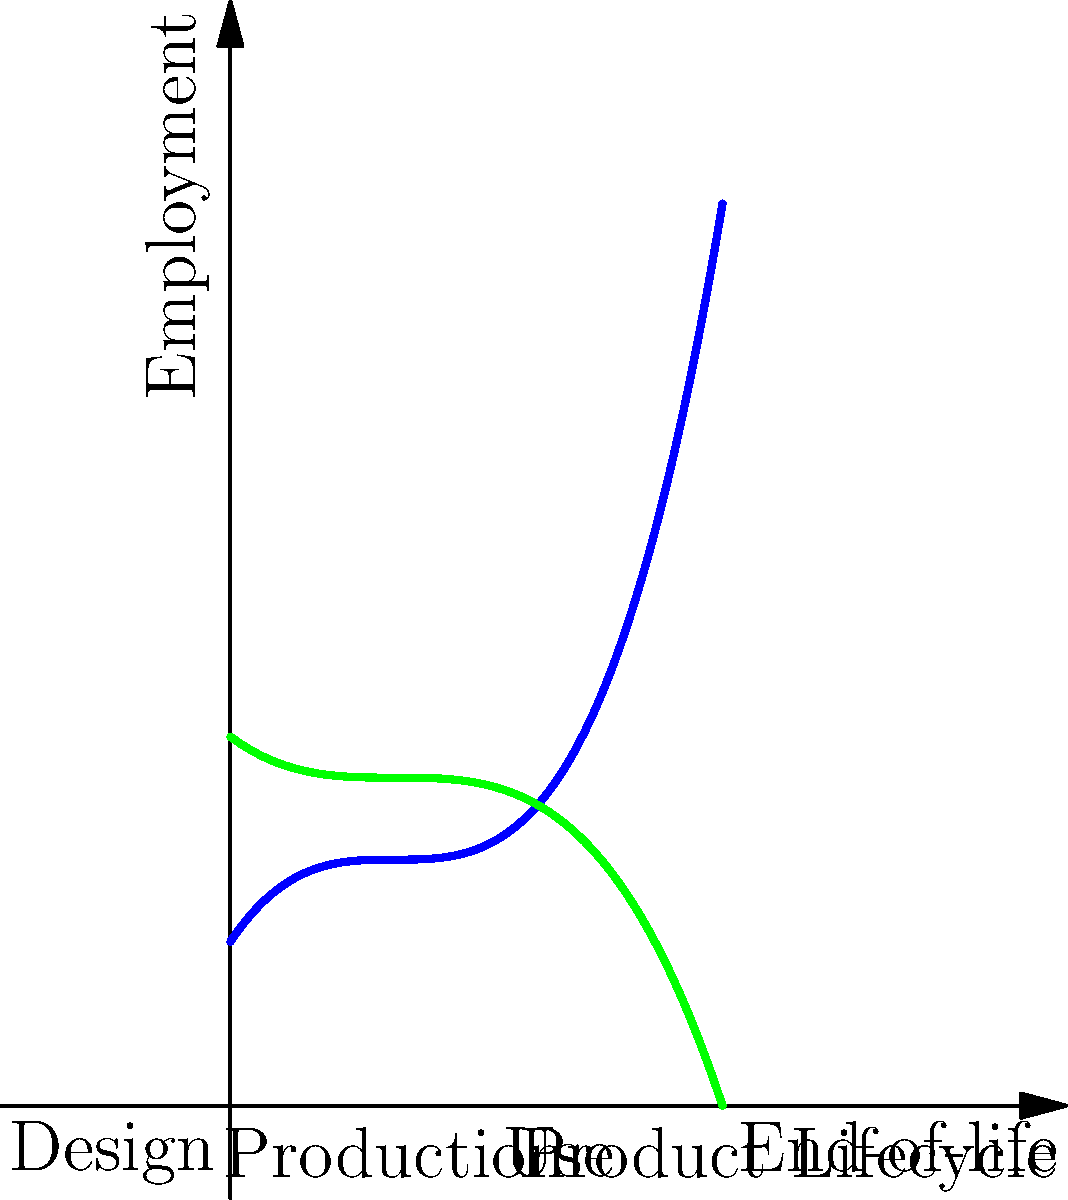In the diagram above, which model demonstrates a more stable employment trend across the product lifecycle, and how might this impact sustainable manufacturing practices? To answer this question, let's analyze the two curves representing the Linear Economy (blue) and Circular Economy (green) models:

1. Linear Economy (Blue Curve):
   - Shows high employment during the design and production phases
   - Employment declines sharply during the use phase
   - Slight increase in employment at the end-of-life phase

2. Circular Economy (Green Curve):
   - More consistent employment levels across all phases
   - Lower peak in the design and production phases compared to the linear model
   - Maintains higher employment during the use phase
   - Significant increase in employment at the end-of-life phase

3. Impact on Sustainable Manufacturing:
   - The Circular Economy model promotes more stable employment throughout the product lifecycle
   - It encourages job creation in repair, refurbishment, and recycling (use and end-of-life phases)
   - This model aligns with sustainable practices by extending product life and reducing waste

4. Benefits for Sustainability:
   - Reduces the need for raw materials and energy in production
   - Creates new job opportunities in circular economy activities
   - Promotes skills development in areas like product design for longevity and recyclability

In conclusion, the Circular Economy model demonstrates a more stable employment trend across the product lifecycle. This stability can support sustainable manufacturing practices by creating diverse, long-term job opportunities and promoting resource efficiency.
Answer: Circular Economy model; stable employment supports sustainable practices through diverse, long-term jobs and resource efficiency. 